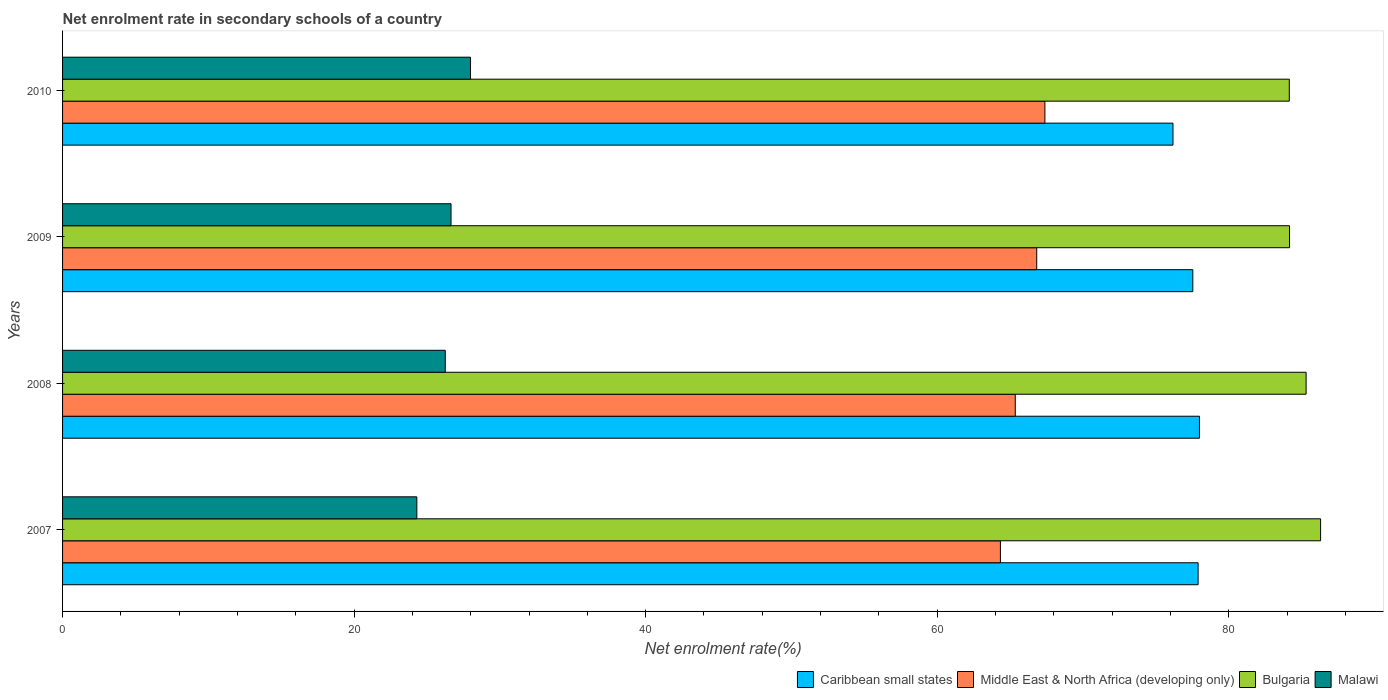How many groups of bars are there?
Your answer should be very brief. 4. How many bars are there on the 1st tick from the bottom?
Your response must be concise. 4. What is the net enrolment rate in secondary schools in Middle East & North Africa (developing only) in 2010?
Provide a succinct answer. 67.39. Across all years, what is the maximum net enrolment rate in secondary schools in Bulgaria?
Offer a terse response. 86.3. Across all years, what is the minimum net enrolment rate in secondary schools in Malawi?
Your answer should be compact. 24.3. In which year was the net enrolment rate in secondary schools in Malawi maximum?
Offer a terse response. 2010. In which year was the net enrolment rate in secondary schools in Malawi minimum?
Provide a short and direct response. 2007. What is the total net enrolment rate in secondary schools in Bulgaria in the graph?
Your answer should be compact. 339.93. What is the difference between the net enrolment rate in secondary schools in Caribbean small states in 2007 and that in 2010?
Provide a succinct answer. 1.72. What is the difference between the net enrolment rate in secondary schools in Bulgaria in 2010 and the net enrolment rate in secondary schools in Malawi in 2008?
Ensure brevity in your answer.  57.9. What is the average net enrolment rate in secondary schools in Malawi per year?
Offer a very short reply. 26.3. In the year 2009, what is the difference between the net enrolment rate in secondary schools in Middle East & North Africa (developing only) and net enrolment rate in secondary schools in Bulgaria?
Give a very brief answer. -17.34. In how many years, is the net enrolment rate in secondary schools in Malawi greater than 20 %?
Ensure brevity in your answer.  4. What is the ratio of the net enrolment rate in secondary schools in Middle East & North Africa (developing only) in 2009 to that in 2010?
Your response must be concise. 0.99. What is the difference between the highest and the second highest net enrolment rate in secondary schools in Caribbean small states?
Make the answer very short. 0.09. What is the difference between the highest and the lowest net enrolment rate in secondary schools in Middle East & North Africa (developing only)?
Provide a short and direct response. 3.05. In how many years, is the net enrolment rate in secondary schools in Malawi greater than the average net enrolment rate in secondary schools in Malawi taken over all years?
Your answer should be very brief. 2. Is the sum of the net enrolment rate in secondary schools in Bulgaria in 2008 and 2009 greater than the maximum net enrolment rate in secondary schools in Caribbean small states across all years?
Provide a short and direct response. Yes. Is it the case that in every year, the sum of the net enrolment rate in secondary schools in Bulgaria and net enrolment rate in secondary schools in Malawi is greater than the sum of net enrolment rate in secondary schools in Middle East & North Africa (developing only) and net enrolment rate in secondary schools in Caribbean small states?
Make the answer very short. No. What does the 4th bar from the top in 2008 represents?
Provide a short and direct response. Caribbean small states. What does the 4th bar from the bottom in 2008 represents?
Offer a very short reply. Malawi. Are all the bars in the graph horizontal?
Your answer should be compact. Yes. How many years are there in the graph?
Keep it short and to the point. 4. What is the difference between two consecutive major ticks on the X-axis?
Give a very brief answer. 20. Are the values on the major ticks of X-axis written in scientific E-notation?
Make the answer very short. No. Does the graph contain any zero values?
Offer a terse response. No. How many legend labels are there?
Offer a very short reply. 4. What is the title of the graph?
Your answer should be very brief. Net enrolment rate in secondary schools of a country. Does "North America" appear as one of the legend labels in the graph?
Your answer should be very brief. No. What is the label or title of the X-axis?
Provide a short and direct response. Net enrolment rate(%). What is the Net enrolment rate(%) of Caribbean small states in 2007?
Keep it short and to the point. 77.9. What is the Net enrolment rate(%) of Middle East & North Africa (developing only) in 2007?
Your response must be concise. 64.34. What is the Net enrolment rate(%) in Bulgaria in 2007?
Provide a short and direct response. 86.3. What is the Net enrolment rate(%) of Malawi in 2007?
Give a very brief answer. 24.3. What is the Net enrolment rate(%) of Caribbean small states in 2008?
Offer a very short reply. 77.99. What is the Net enrolment rate(%) in Middle East & North Africa (developing only) in 2008?
Give a very brief answer. 65.36. What is the Net enrolment rate(%) in Bulgaria in 2008?
Provide a succinct answer. 85.31. What is the Net enrolment rate(%) in Malawi in 2008?
Give a very brief answer. 26.25. What is the Net enrolment rate(%) of Caribbean small states in 2009?
Give a very brief answer. 77.54. What is the Net enrolment rate(%) of Middle East & North Africa (developing only) in 2009?
Your response must be concise. 66.83. What is the Net enrolment rate(%) of Bulgaria in 2009?
Offer a terse response. 84.17. What is the Net enrolment rate(%) of Malawi in 2009?
Your response must be concise. 26.65. What is the Net enrolment rate(%) of Caribbean small states in 2010?
Make the answer very short. 76.18. What is the Net enrolment rate(%) in Middle East & North Africa (developing only) in 2010?
Your answer should be compact. 67.39. What is the Net enrolment rate(%) of Bulgaria in 2010?
Offer a very short reply. 84.15. What is the Net enrolment rate(%) in Malawi in 2010?
Provide a succinct answer. 27.99. Across all years, what is the maximum Net enrolment rate(%) in Caribbean small states?
Make the answer very short. 77.99. Across all years, what is the maximum Net enrolment rate(%) of Middle East & North Africa (developing only)?
Your answer should be compact. 67.39. Across all years, what is the maximum Net enrolment rate(%) in Bulgaria?
Keep it short and to the point. 86.3. Across all years, what is the maximum Net enrolment rate(%) in Malawi?
Your answer should be very brief. 27.99. Across all years, what is the minimum Net enrolment rate(%) in Caribbean small states?
Offer a very short reply. 76.18. Across all years, what is the minimum Net enrolment rate(%) of Middle East & North Africa (developing only)?
Your answer should be very brief. 64.34. Across all years, what is the minimum Net enrolment rate(%) in Bulgaria?
Give a very brief answer. 84.15. Across all years, what is the minimum Net enrolment rate(%) of Malawi?
Your answer should be very brief. 24.3. What is the total Net enrolment rate(%) of Caribbean small states in the graph?
Make the answer very short. 309.6. What is the total Net enrolment rate(%) in Middle East & North Africa (developing only) in the graph?
Provide a succinct answer. 263.91. What is the total Net enrolment rate(%) of Bulgaria in the graph?
Your answer should be compact. 339.93. What is the total Net enrolment rate(%) of Malawi in the graph?
Offer a terse response. 105.19. What is the difference between the Net enrolment rate(%) of Caribbean small states in 2007 and that in 2008?
Your answer should be compact. -0.09. What is the difference between the Net enrolment rate(%) of Middle East & North Africa (developing only) in 2007 and that in 2008?
Offer a very short reply. -1.02. What is the difference between the Net enrolment rate(%) in Bulgaria in 2007 and that in 2008?
Provide a short and direct response. 0.99. What is the difference between the Net enrolment rate(%) of Malawi in 2007 and that in 2008?
Your answer should be very brief. -1.95. What is the difference between the Net enrolment rate(%) of Caribbean small states in 2007 and that in 2009?
Give a very brief answer. 0.36. What is the difference between the Net enrolment rate(%) in Middle East & North Africa (developing only) in 2007 and that in 2009?
Provide a succinct answer. -2.49. What is the difference between the Net enrolment rate(%) of Bulgaria in 2007 and that in 2009?
Make the answer very short. 2.13. What is the difference between the Net enrolment rate(%) of Malawi in 2007 and that in 2009?
Offer a terse response. -2.35. What is the difference between the Net enrolment rate(%) in Caribbean small states in 2007 and that in 2010?
Offer a terse response. 1.72. What is the difference between the Net enrolment rate(%) in Middle East & North Africa (developing only) in 2007 and that in 2010?
Provide a succinct answer. -3.05. What is the difference between the Net enrolment rate(%) of Bulgaria in 2007 and that in 2010?
Offer a terse response. 2.15. What is the difference between the Net enrolment rate(%) of Malawi in 2007 and that in 2010?
Offer a very short reply. -3.68. What is the difference between the Net enrolment rate(%) of Caribbean small states in 2008 and that in 2009?
Ensure brevity in your answer.  0.46. What is the difference between the Net enrolment rate(%) in Middle East & North Africa (developing only) in 2008 and that in 2009?
Your answer should be compact. -1.47. What is the difference between the Net enrolment rate(%) in Bulgaria in 2008 and that in 2009?
Offer a very short reply. 1.14. What is the difference between the Net enrolment rate(%) of Malawi in 2008 and that in 2009?
Offer a very short reply. -0.4. What is the difference between the Net enrolment rate(%) of Caribbean small states in 2008 and that in 2010?
Provide a short and direct response. 1.82. What is the difference between the Net enrolment rate(%) in Middle East & North Africa (developing only) in 2008 and that in 2010?
Offer a terse response. -2.03. What is the difference between the Net enrolment rate(%) of Bulgaria in 2008 and that in 2010?
Offer a very short reply. 1.15. What is the difference between the Net enrolment rate(%) of Malawi in 2008 and that in 2010?
Ensure brevity in your answer.  -1.73. What is the difference between the Net enrolment rate(%) of Caribbean small states in 2009 and that in 2010?
Make the answer very short. 1.36. What is the difference between the Net enrolment rate(%) in Middle East & North Africa (developing only) in 2009 and that in 2010?
Your answer should be very brief. -0.56. What is the difference between the Net enrolment rate(%) in Bulgaria in 2009 and that in 2010?
Offer a very short reply. 0.02. What is the difference between the Net enrolment rate(%) in Malawi in 2009 and that in 2010?
Your answer should be very brief. -1.34. What is the difference between the Net enrolment rate(%) in Caribbean small states in 2007 and the Net enrolment rate(%) in Middle East & North Africa (developing only) in 2008?
Your answer should be very brief. 12.54. What is the difference between the Net enrolment rate(%) of Caribbean small states in 2007 and the Net enrolment rate(%) of Bulgaria in 2008?
Provide a short and direct response. -7.41. What is the difference between the Net enrolment rate(%) of Caribbean small states in 2007 and the Net enrolment rate(%) of Malawi in 2008?
Provide a succinct answer. 51.65. What is the difference between the Net enrolment rate(%) of Middle East & North Africa (developing only) in 2007 and the Net enrolment rate(%) of Bulgaria in 2008?
Give a very brief answer. -20.97. What is the difference between the Net enrolment rate(%) in Middle East & North Africa (developing only) in 2007 and the Net enrolment rate(%) in Malawi in 2008?
Your answer should be compact. 38.08. What is the difference between the Net enrolment rate(%) of Bulgaria in 2007 and the Net enrolment rate(%) of Malawi in 2008?
Give a very brief answer. 60.05. What is the difference between the Net enrolment rate(%) in Caribbean small states in 2007 and the Net enrolment rate(%) in Middle East & North Africa (developing only) in 2009?
Keep it short and to the point. 11.07. What is the difference between the Net enrolment rate(%) of Caribbean small states in 2007 and the Net enrolment rate(%) of Bulgaria in 2009?
Offer a terse response. -6.27. What is the difference between the Net enrolment rate(%) in Caribbean small states in 2007 and the Net enrolment rate(%) in Malawi in 2009?
Provide a short and direct response. 51.25. What is the difference between the Net enrolment rate(%) of Middle East & North Africa (developing only) in 2007 and the Net enrolment rate(%) of Bulgaria in 2009?
Ensure brevity in your answer.  -19.83. What is the difference between the Net enrolment rate(%) in Middle East & North Africa (developing only) in 2007 and the Net enrolment rate(%) in Malawi in 2009?
Offer a terse response. 37.69. What is the difference between the Net enrolment rate(%) in Bulgaria in 2007 and the Net enrolment rate(%) in Malawi in 2009?
Make the answer very short. 59.65. What is the difference between the Net enrolment rate(%) in Caribbean small states in 2007 and the Net enrolment rate(%) in Middle East & North Africa (developing only) in 2010?
Give a very brief answer. 10.51. What is the difference between the Net enrolment rate(%) of Caribbean small states in 2007 and the Net enrolment rate(%) of Bulgaria in 2010?
Make the answer very short. -6.26. What is the difference between the Net enrolment rate(%) in Caribbean small states in 2007 and the Net enrolment rate(%) in Malawi in 2010?
Offer a terse response. 49.91. What is the difference between the Net enrolment rate(%) of Middle East & North Africa (developing only) in 2007 and the Net enrolment rate(%) of Bulgaria in 2010?
Provide a short and direct response. -19.82. What is the difference between the Net enrolment rate(%) of Middle East & North Africa (developing only) in 2007 and the Net enrolment rate(%) of Malawi in 2010?
Ensure brevity in your answer.  36.35. What is the difference between the Net enrolment rate(%) in Bulgaria in 2007 and the Net enrolment rate(%) in Malawi in 2010?
Your answer should be compact. 58.32. What is the difference between the Net enrolment rate(%) in Caribbean small states in 2008 and the Net enrolment rate(%) in Middle East & North Africa (developing only) in 2009?
Provide a succinct answer. 11.16. What is the difference between the Net enrolment rate(%) in Caribbean small states in 2008 and the Net enrolment rate(%) in Bulgaria in 2009?
Provide a short and direct response. -6.18. What is the difference between the Net enrolment rate(%) of Caribbean small states in 2008 and the Net enrolment rate(%) of Malawi in 2009?
Ensure brevity in your answer.  51.34. What is the difference between the Net enrolment rate(%) in Middle East & North Africa (developing only) in 2008 and the Net enrolment rate(%) in Bulgaria in 2009?
Provide a short and direct response. -18.82. What is the difference between the Net enrolment rate(%) in Middle East & North Africa (developing only) in 2008 and the Net enrolment rate(%) in Malawi in 2009?
Offer a terse response. 38.71. What is the difference between the Net enrolment rate(%) in Bulgaria in 2008 and the Net enrolment rate(%) in Malawi in 2009?
Your answer should be very brief. 58.66. What is the difference between the Net enrolment rate(%) in Caribbean small states in 2008 and the Net enrolment rate(%) in Middle East & North Africa (developing only) in 2010?
Offer a terse response. 10.6. What is the difference between the Net enrolment rate(%) of Caribbean small states in 2008 and the Net enrolment rate(%) of Bulgaria in 2010?
Provide a succinct answer. -6.16. What is the difference between the Net enrolment rate(%) of Caribbean small states in 2008 and the Net enrolment rate(%) of Malawi in 2010?
Your answer should be very brief. 50.01. What is the difference between the Net enrolment rate(%) of Middle East & North Africa (developing only) in 2008 and the Net enrolment rate(%) of Bulgaria in 2010?
Offer a terse response. -18.8. What is the difference between the Net enrolment rate(%) of Middle East & North Africa (developing only) in 2008 and the Net enrolment rate(%) of Malawi in 2010?
Offer a very short reply. 37.37. What is the difference between the Net enrolment rate(%) of Bulgaria in 2008 and the Net enrolment rate(%) of Malawi in 2010?
Ensure brevity in your answer.  57.32. What is the difference between the Net enrolment rate(%) of Caribbean small states in 2009 and the Net enrolment rate(%) of Middle East & North Africa (developing only) in 2010?
Make the answer very short. 10.15. What is the difference between the Net enrolment rate(%) in Caribbean small states in 2009 and the Net enrolment rate(%) in Bulgaria in 2010?
Offer a terse response. -6.62. What is the difference between the Net enrolment rate(%) of Caribbean small states in 2009 and the Net enrolment rate(%) of Malawi in 2010?
Offer a terse response. 49.55. What is the difference between the Net enrolment rate(%) of Middle East & North Africa (developing only) in 2009 and the Net enrolment rate(%) of Bulgaria in 2010?
Keep it short and to the point. -17.33. What is the difference between the Net enrolment rate(%) in Middle East & North Africa (developing only) in 2009 and the Net enrolment rate(%) in Malawi in 2010?
Ensure brevity in your answer.  38.84. What is the difference between the Net enrolment rate(%) in Bulgaria in 2009 and the Net enrolment rate(%) in Malawi in 2010?
Your answer should be very brief. 56.19. What is the average Net enrolment rate(%) in Caribbean small states per year?
Your response must be concise. 77.4. What is the average Net enrolment rate(%) in Middle East & North Africa (developing only) per year?
Keep it short and to the point. 65.98. What is the average Net enrolment rate(%) of Bulgaria per year?
Offer a terse response. 84.98. What is the average Net enrolment rate(%) of Malawi per year?
Keep it short and to the point. 26.3. In the year 2007, what is the difference between the Net enrolment rate(%) in Caribbean small states and Net enrolment rate(%) in Middle East & North Africa (developing only)?
Your response must be concise. 13.56. In the year 2007, what is the difference between the Net enrolment rate(%) in Caribbean small states and Net enrolment rate(%) in Bulgaria?
Your response must be concise. -8.4. In the year 2007, what is the difference between the Net enrolment rate(%) of Caribbean small states and Net enrolment rate(%) of Malawi?
Ensure brevity in your answer.  53.59. In the year 2007, what is the difference between the Net enrolment rate(%) of Middle East & North Africa (developing only) and Net enrolment rate(%) of Bulgaria?
Ensure brevity in your answer.  -21.96. In the year 2007, what is the difference between the Net enrolment rate(%) in Middle East & North Africa (developing only) and Net enrolment rate(%) in Malawi?
Ensure brevity in your answer.  40.03. In the year 2007, what is the difference between the Net enrolment rate(%) of Bulgaria and Net enrolment rate(%) of Malawi?
Provide a succinct answer. 62. In the year 2008, what is the difference between the Net enrolment rate(%) of Caribbean small states and Net enrolment rate(%) of Middle East & North Africa (developing only)?
Your answer should be compact. 12.64. In the year 2008, what is the difference between the Net enrolment rate(%) of Caribbean small states and Net enrolment rate(%) of Bulgaria?
Provide a short and direct response. -7.32. In the year 2008, what is the difference between the Net enrolment rate(%) of Caribbean small states and Net enrolment rate(%) of Malawi?
Your answer should be compact. 51.74. In the year 2008, what is the difference between the Net enrolment rate(%) of Middle East & North Africa (developing only) and Net enrolment rate(%) of Bulgaria?
Offer a very short reply. -19.95. In the year 2008, what is the difference between the Net enrolment rate(%) of Middle East & North Africa (developing only) and Net enrolment rate(%) of Malawi?
Make the answer very short. 39.1. In the year 2008, what is the difference between the Net enrolment rate(%) in Bulgaria and Net enrolment rate(%) in Malawi?
Offer a terse response. 59.06. In the year 2009, what is the difference between the Net enrolment rate(%) in Caribbean small states and Net enrolment rate(%) in Middle East & North Africa (developing only)?
Keep it short and to the point. 10.71. In the year 2009, what is the difference between the Net enrolment rate(%) in Caribbean small states and Net enrolment rate(%) in Bulgaria?
Your answer should be very brief. -6.63. In the year 2009, what is the difference between the Net enrolment rate(%) in Caribbean small states and Net enrolment rate(%) in Malawi?
Provide a short and direct response. 50.89. In the year 2009, what is the difference between the Net enrolment rate(%) in Middle East & North Africa (developing only) and Net enrolment rate(%) in Bulgaria?
Your answer should be compact. -17.34. In the year 2009, what is the difference between the Net enrolment rate(%) of Middle East & North Africa (developing only) and Net enrolment rate(%) of Malawi?
Offer a terse response. 40.18. In the year 2009, what is the difference between the Net enrolment rate(%) in Bulgaria and Net enrolment rate(%) in Malawi?
Your answer should be compact. 57.52. In the year 2010, what is the difference between the Net enrolment rate(%) of Caribbean small states and Net enrolment rate(%) of Middle East & North Africa (developing only)?
Provide a short and direct response. 8.79. In the year 2010, what is the difference between the Net enrolment rate(%) of Caribbean small states and Net enrolment rate(%) of Bulgaria?
Offer a very short reply. -7.98. In the year 2010, what is the difference between the Net enrolment rate(%) of Caribbean small states and Net enrolment rate(%) of Malawi?
Provide a succinct answer. 48.19. In the year 2010, what is the difference between the Net enrolment rate(%) of Middle East & North Africa (developing only) and Net enrolment rate(%) of Bulgaria?
Provide a short and direct response. -16.77. In the year 2010, what is the difference between the Net enrolment rate(%) of Middle East & North Africa (developing only) and Net enrolment rate(%) of Malawi?
Your answer should be compact. 39.4. In the year 2010, what is the difference between the Net enrolment rate(%) of Bulgaria and Net enrolment rate(%) of Malawi?
Make the answer very short. 56.17. What is the ratio of the Net enrolment rate(%) of Middle East & North Africa (developing only) in 2007 to that in 2008?
Provide a succinct answer. 0.98. What is the ratio of the Net enrolment rate(%) of Bulgaria in 2007 to that in 2008?
Ensure brevity in your answer.  1.01. What is the ratio of the Net enrolment rate(%) of Malawi in 2007 to that in 2008?
Provide a short and direct response. 0.93. What is the ratio of the Net enrolment rate(%) of Middle East & North Africa (developing only) in 2007 to that in 2009?
Your answer should be very brief. 0.96. What is the ratio of the Net enrolment rate(%) in Bulgaria in 2007 to that in 2009?
Ensure brevity in your answer.  1.03. What is the ratio of the Net enrolment rate(%) in Malawi in 2007 to that in 2009?
Keep it short and to the point. 0.91. What is the ratio of the Net enrolment rate(%) of Caribbean small states in 2007 to that in 2010?
Your answer should be very brief. 1.02. What is the ratio of the Net enrolment rate(%) in Middle East & North Africa (developing only) in 2007 to that in 2010?
Ensure brevity in your answer.  0.95. What is the ratio of the Net enrolment rate(%) of Bulgaria in 2007 to that in 2010?
Offer a terse response. 1.03. What is the ratio of the Net enrolment rate(%) in Malawi in 2007 to that in 2010?
Make the answer very short. 0.87. What is the ratio of the Net enrolment rate(%) of Caribbean small states in 2008 to that in 2009?
Keep it short and to the point. 1.01. What is the ratio of the Net enrolment rate(%) in Middle East & North Africa (developing only) in 2008 to that in 2009?
Provide a succinct answer. 0.98. What is the ratio of the Net enrolment rate(%) in Bulgaria in 2008 to that in 2009?
Your response must be concise. 1.01. What is the ratio of the Net enrolment rate(%) in Malawi in 2008 to that in 2009?
Offer a very short reply. 0.99. What is the ratio of the Net enrolment rate(%) of Caribbean small states in 2008 to that in 2010?
Keep it short and to the point. 1.02. What is the ratio of the Net enrolment rate(%) in Middle East & North Africa (developing only) in 2008 to that in 2010?
Your answer should be very brief. 0.97. What is the ratio of the Net enrolment rate(%) in Bulgaria in 2008 to that in 2010?
Your answer should be very brief. 1.01. What is the ratio of the Net enrolment rate(%) in Malawi in 2008 to that in 2010?
Offer a terse response. 0.94. What is the ratio of the Net enrolment rate(%) of Caribbean small states in 2009 to that in 2010?
Keep it short and to the point. 1.02. What is the ratio of the Net enrolment rate(%) in Middle East & North Africa (developing only) in 2009 to that in 2010?
Offer a very short reply. 0.99. What is the ratio of the Net enrolment rate(%) of Malawi in 2009 to that in 2010?
Your answer should be compact. 0.95. What is the difference between the highest and the second highest Net enrolment rate(%) of Caribbean small states?
Offer a very short reply. 0.09. What is the difference between the highest and the second highest Net enrolment rate(%) of Middle East & North Africa (developing only)?
Keep it short and to the point. 0.56. What is the difference between the highest and the second highest Net enrolment rate(%) of Bulgaria?
Provide a short and direct response. 0.99. What is the difference between the highest and the second highest Net enrolment rate(%) of Malawi?
Keep it short and to the point. 1.34. What is the difference between the highest and the lowest Net enrolment rate(%) of Caribbean small states?
Your answer should be very brief. 1.82. What is the difference between the highest and the lowest Net enrolment rate(%) of Middle East & North Africa (developing only)?
Your answer should be very brief. 3.05. What is the difference between the highest and the lowest Net enrolment rate(%) of Bulgaria?
Give a very brief answer. 2.15. What is the difference between the highest and the lowest Net enrolment rate(%) of Malawi?
Give a very brief answer. 3.68. 